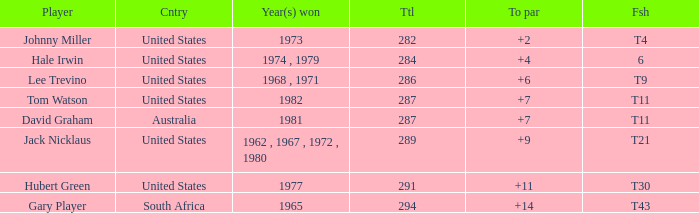WHAT IS THE TO PAR WITH A FINISH OF T11, FOR DAVID GRAHAM? 7.0. 